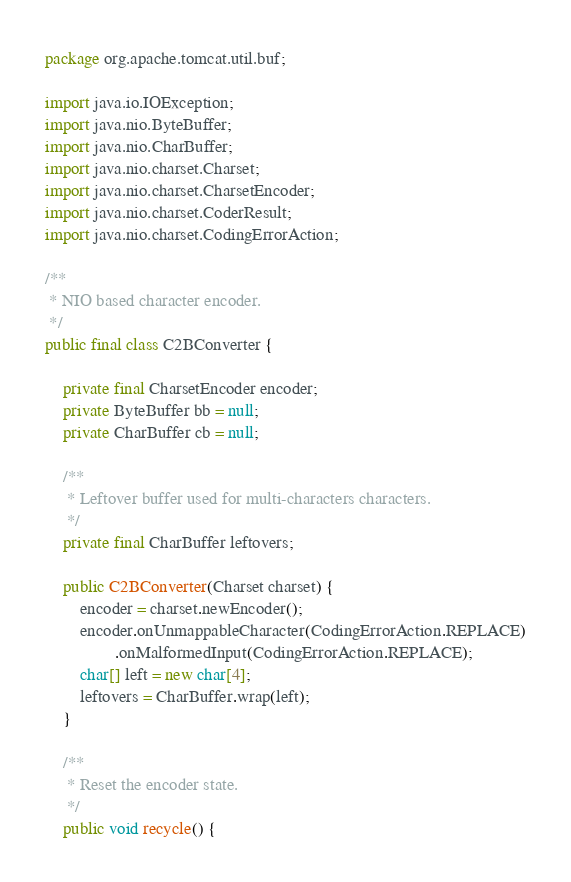<code> <loc_0><loc_0><loc_500><loc_500><_Java_>
package org.apache.tomcat.util.buf;

import java.io.IOException;
import java.nio.ByteBuffer;
import java.nio.CharBuffer;
import java.nio.charset.Charset;
import java.nio.charset.CharsetEncoder;
import java.nio.charset.CoderResult;
import java.nio.charset.CodingErrorAction;

/**
 * NIO based character encoder.
 */
public final class C2BConverter {

    private final CharsetEncoder encoder;
    private ByteBuffer bb = null;
    private CharBuffer cb = null;

    /**
     * Leftover buffer used for multi-characters characters.
     */
    private final CharBuffer leftovers;

    public C2BConverter(Charset charset) {
        encoder = charset.newEncoder();
        encoder.onUnmappableCharacter(CodingErrorAction.REPLACE)
                .onMalformedInput(CodingErrorAction.REPLACE);
        char[] left = new char[4];
        leftovers = CharBuffer.wrap(left);
    }

    /**
     * Reset the encoder state.
     */
    public void recycle() {</code> 